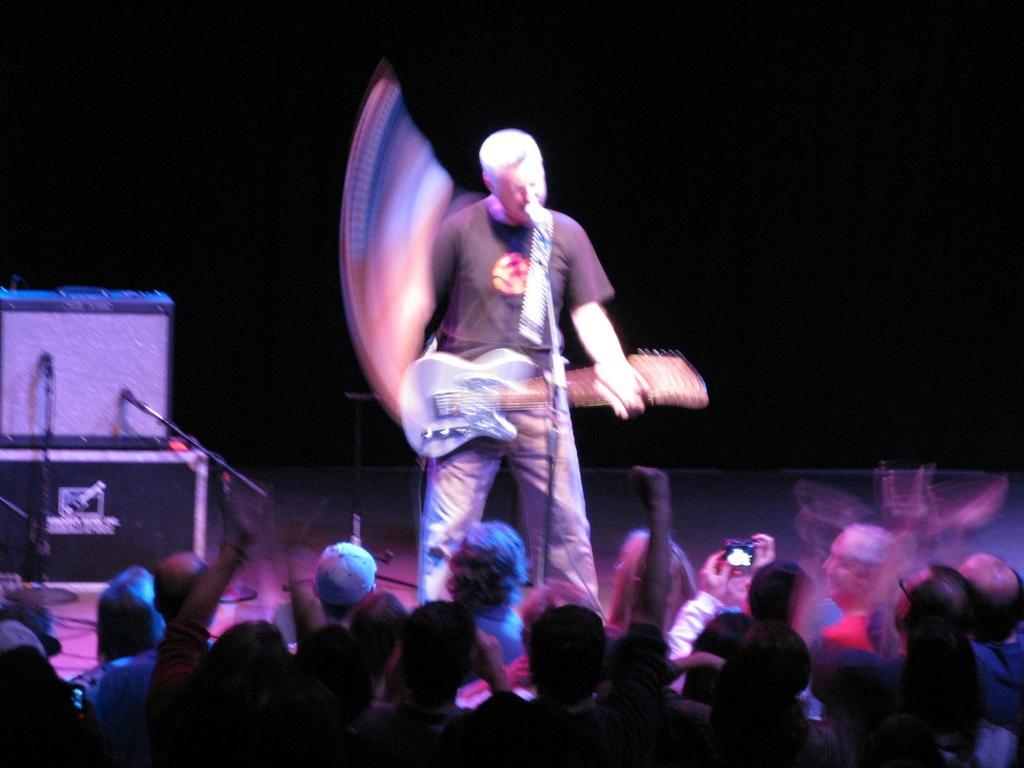Could you give a brief overview of what you see in this image? In the image it looks like a concert, there is a man standing on the stage and playing the guitar, behind him there are some equipment and in front of the stage there is crowd. 